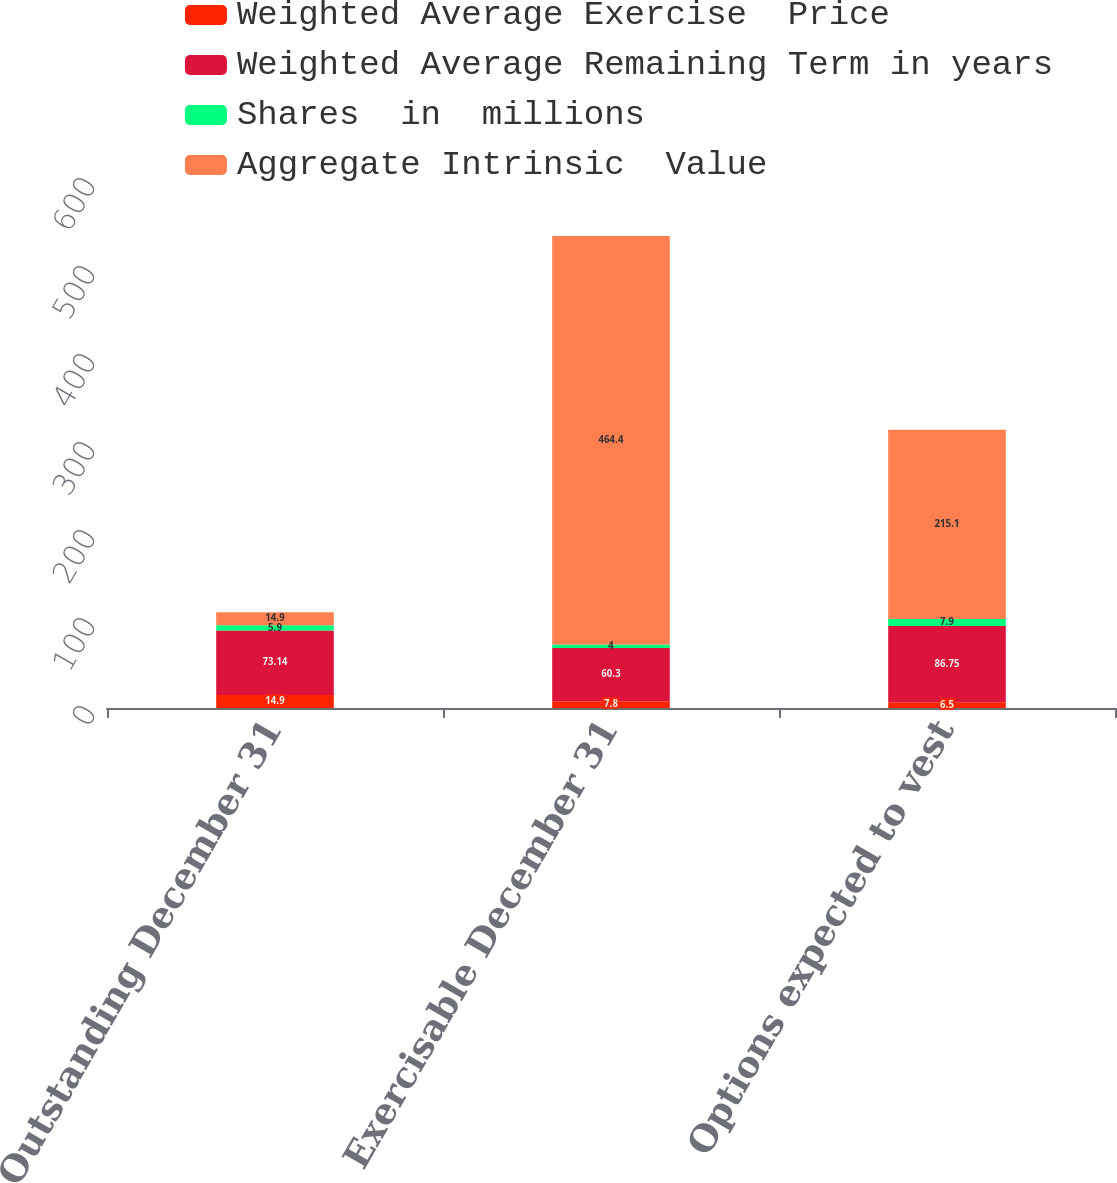<chart> <loc_0><loc_0><loc_500><loc_500><stacked_bar_chart><ecel><fcel>Outstanding December 31<fcel>Exercisable December 31<fcel>Options expected to vest<nl><fcel>Weighted Average Exercise  Price<fcel>14.9<fcel>7.8<fcel>6.5<nl><fcel>Weighted Average Remaining Term in years<fcel>73.14<fcel>60.3<fcel>86.75<nl><fcel>Shares  in  millions<fcel>5.9<fcel>4<fcel>7.9<nl><fcel>Aggregate Intrinsic  Value<fcel>14.9<fcel>464.4<fcel>215.1<nl></chart> 